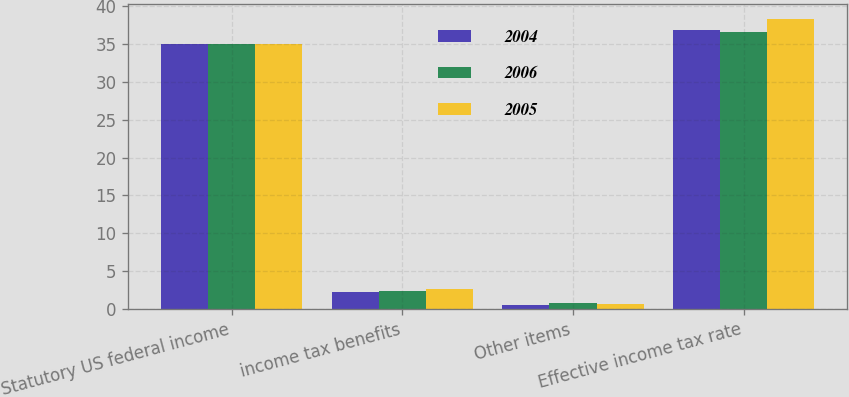Convert chart to OTSL. <chart><loc_0><loc_0><loc_500><loc_500><stacked_bar_chart><ecel><fcel>Statutory US federal income<fcel>income tax benefits<fcel>Other items<fcel>Effective income tax rate<nl><fcel>2004<fcel>35<fcel>2.3<fcel>0.5<fcel>36.8<nl><fcel>2006<fcel>35<fcel>2.4<fcel>0.8<fcel>36.6<nl><fcel>2005<fcel>35<fcel>2.7<fcel>0.6<fcel>38.3<nl></chart> 